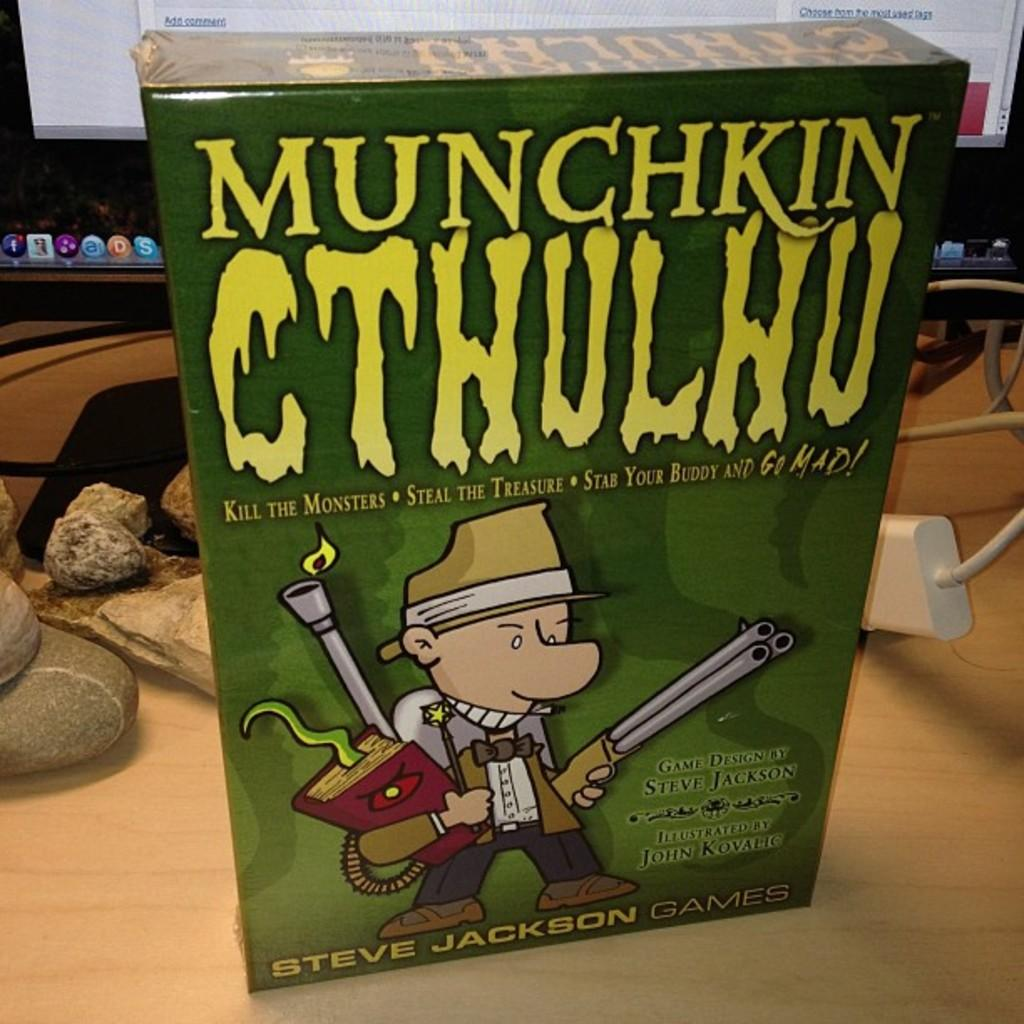<image>
Summarize the visual content of the image. A game called Munchkin CTHULHU sits on a table 